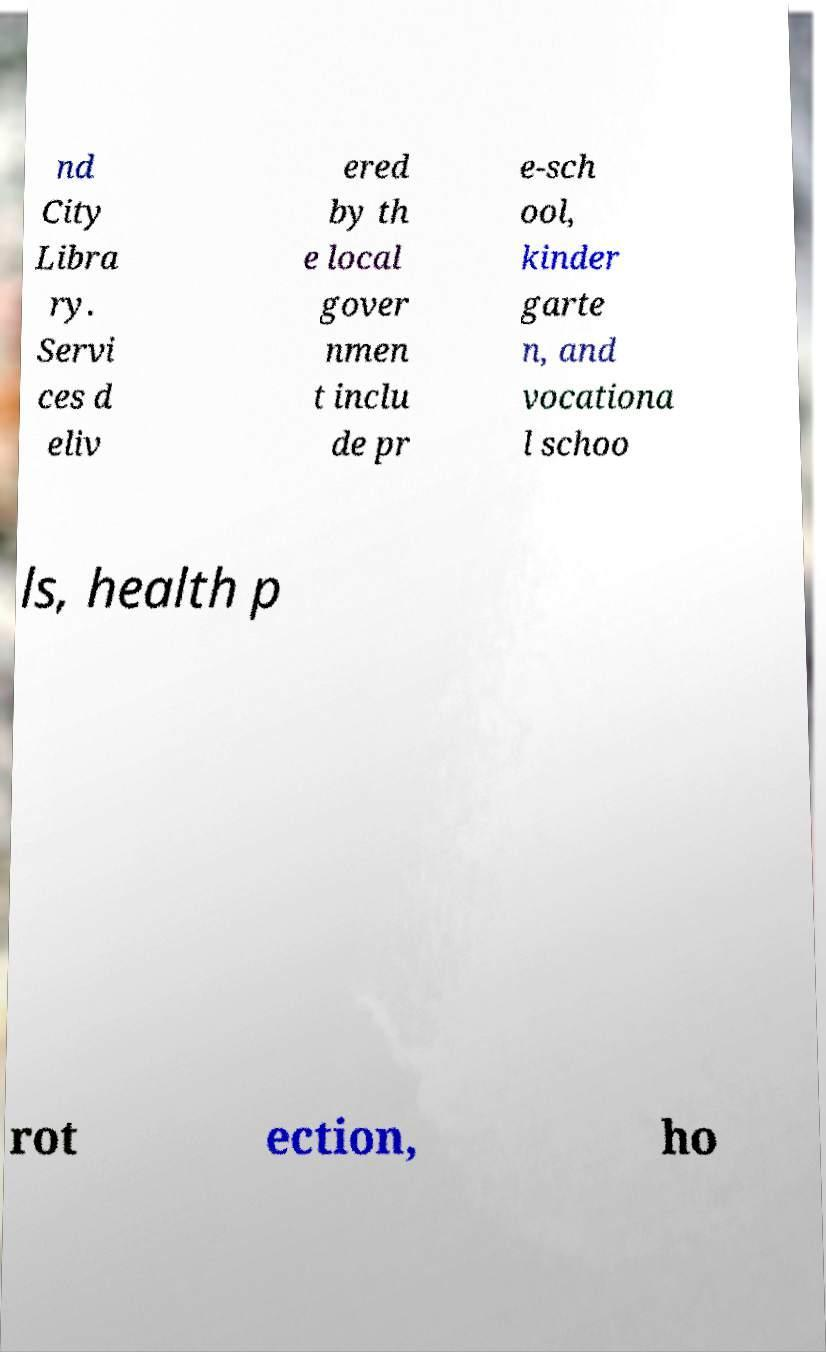For documentation purposes, I need the text within this image transcribed. Could you provide that? nd City Libra ry. Servi ces d eliv ered by th e local gover nmen t inclu de pr e-sch ool, kinder garte n, and vocationa l schoo ls, health p rot ection, ho 